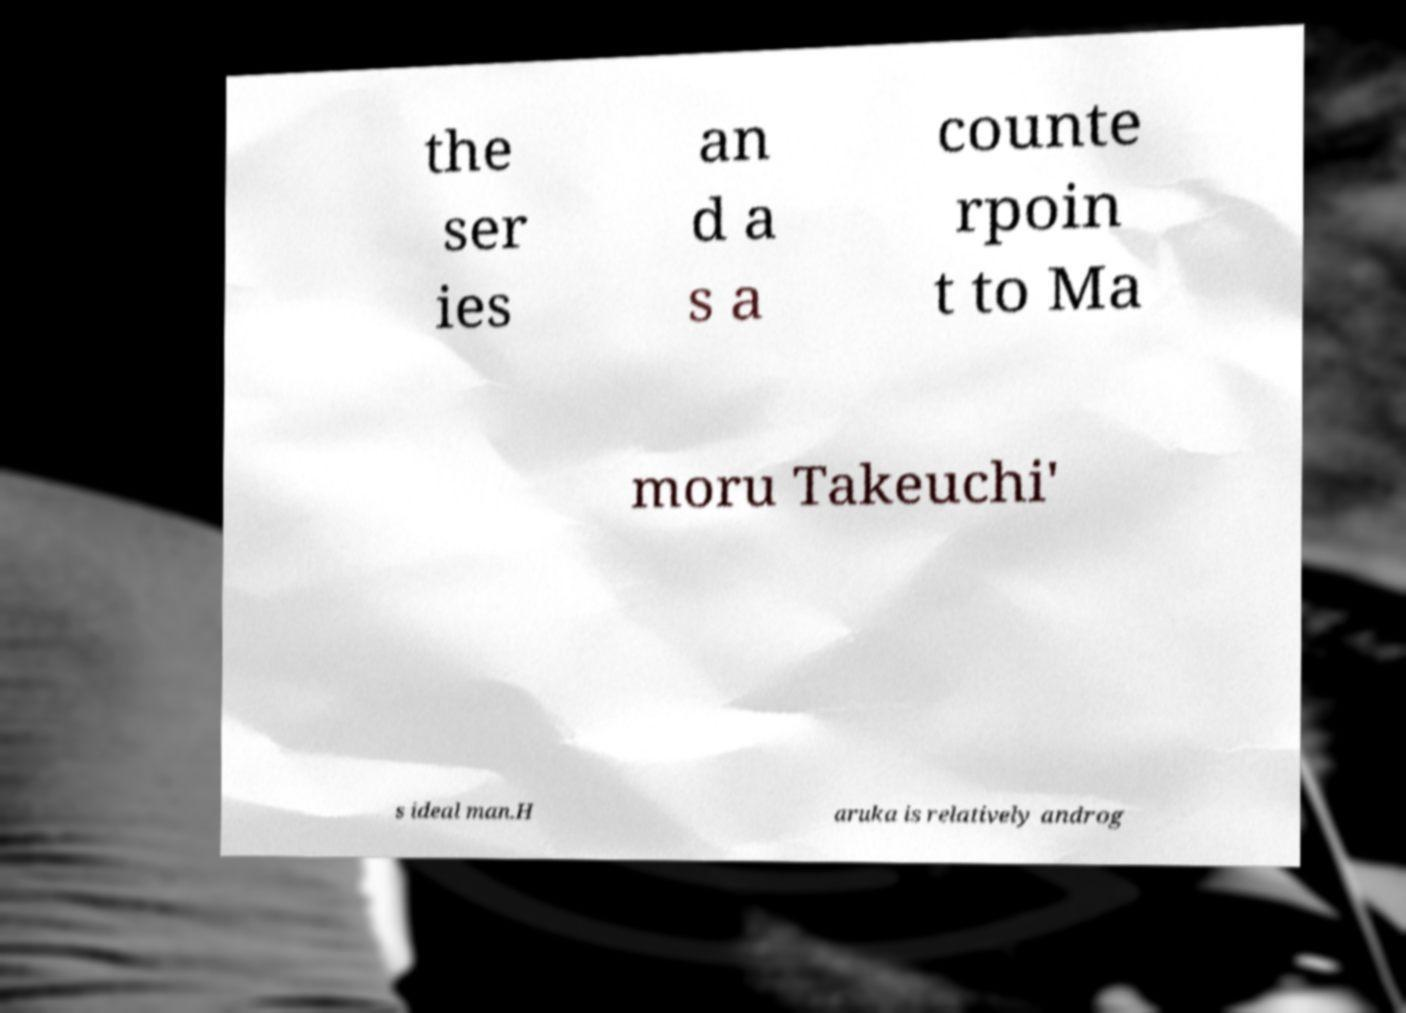Please read and relay the text visible in this image. What does it say? the ser ies an d a s a counte rpoin t to Ma moru Takeuchi' s ideal man.H aruka is relatively androg 